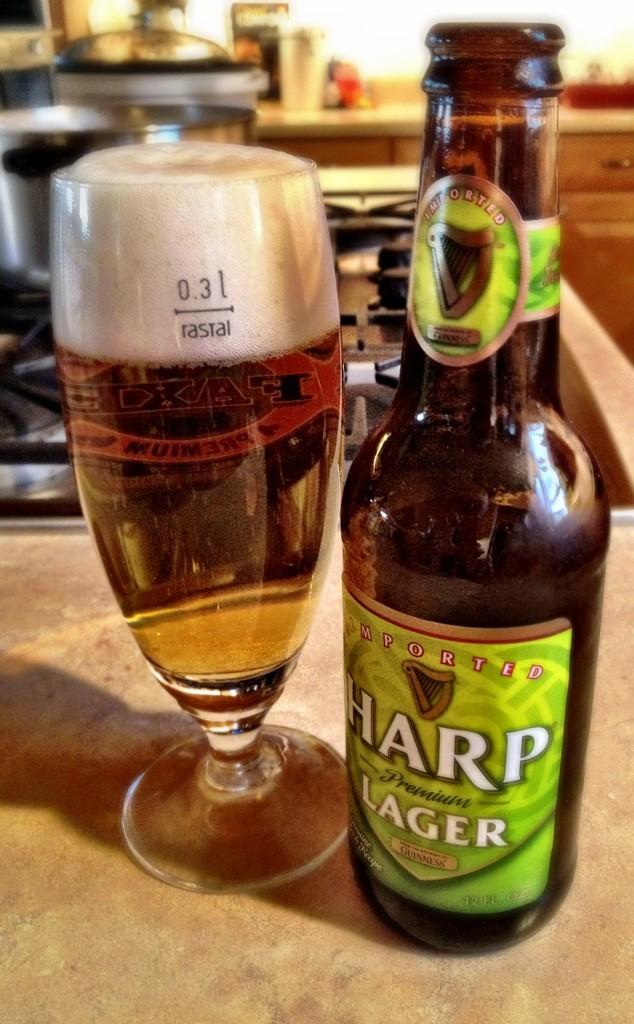<image>
Write a terse but informative summary of the picture. A bottle of Harp lager sits next to a full glass of beer. 